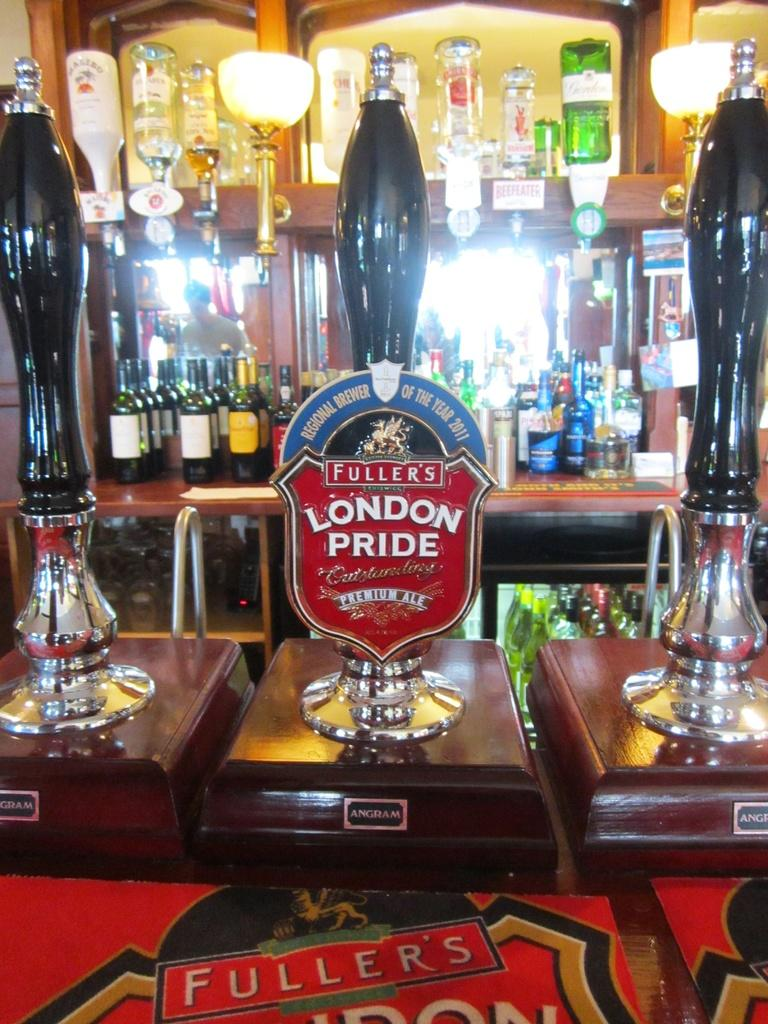Provide a one-sentence caption for the provided image. In a bar there you can get a pint of Fullers London Pride. 